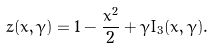Convert formula to latex. <formula><loc_0><loc_0><loc_500><loc_500>z ( x , \gamma ) = 1 - \frac { x ^ { 2 } } { 2 } + \gamma I _ { 3 } ( x , \gamma ) .</formula> 